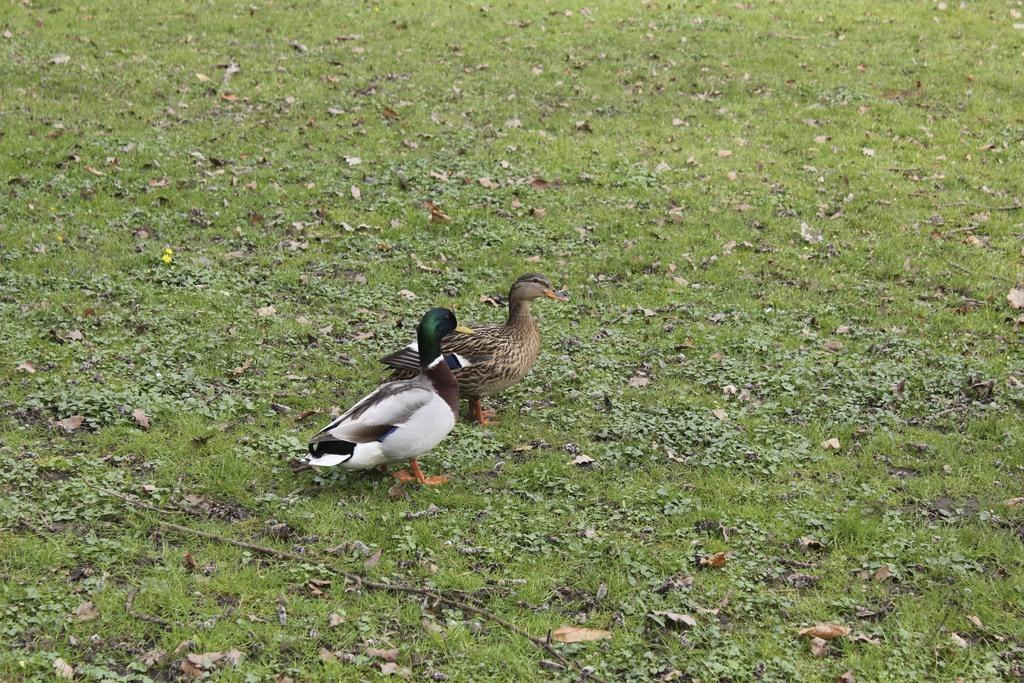How many birds are present in the image? There are two birds in the image. What is the color of the grass on the ground in the image? The grass on the ground in the image is green. What type of toys can be seen in the image? There are no toys present in the image; it features two birds and green grass. What day of the week is depicted in the image? The image does not depict a specific day of the week; it only shows two birds and green grass. 